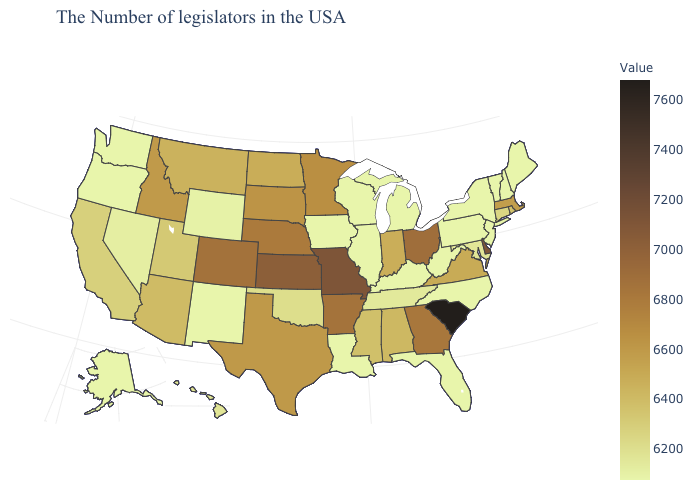Does Colorado have the highest value in the West?
Answer briefly. Yes. Which states have the lowest value in the South?
Short answer required. North Carolina, West Virginia, Florida, Kentucky, Louisiana. Which states have the highest value in the USA?
Write a very short answer. South Carolina. Does Montana have the lowest value in the West?
Give a very brief answer. No. Does South Carolina have the highest value in the USA?
Give a very brief answer. Yes. Does Alaska have the lowest value in the West?
Quick response, please. Yes. 